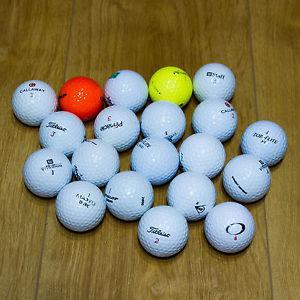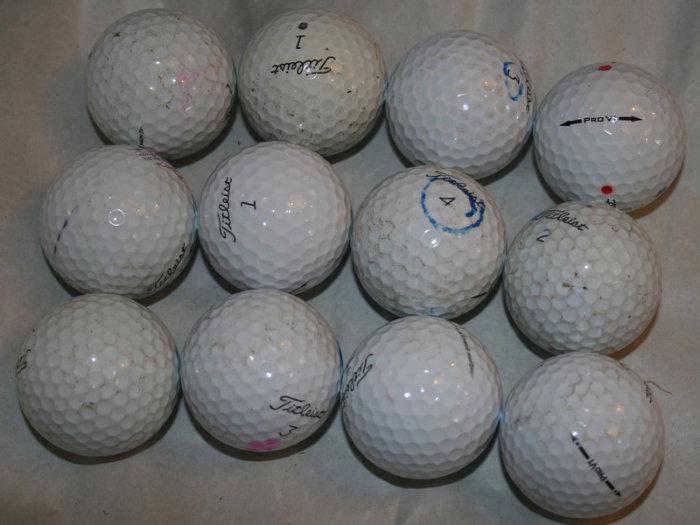The first image is the image on the left, the second image is the image on the right. Given the left and right images, does the statement "In at least one image there is a pile of white golf balls and at least one yellow golf ball." hold true? Answer yes or no. Yes. The first image is the image on the left, the second image is the image on the right. Given the left and right images, does the statement "Some of the balls are not white in one image and all the balls are white in the other image." hold true? Answer yes or no. Yes. 